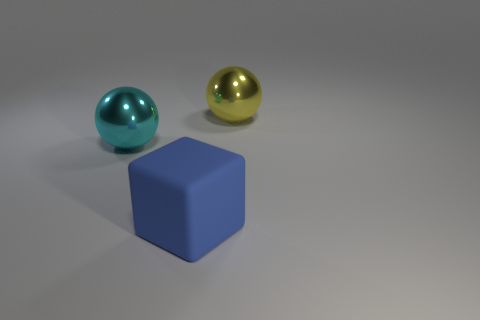Add 3 large brown matte spheres. How many objects exist? 6 Subtract all blocks. How many objects are left? 2 Subtract all yellow shiny objects. Subtract all shiny objects. How many objects are left? 0 Add 3 large yellow metallic balls. How many large yellow metallic balls are left? 4 Add 1 blue cubes. How many blue cubes exist? 2 Subtract 1 yellow spheres. How many objects are left? 2 